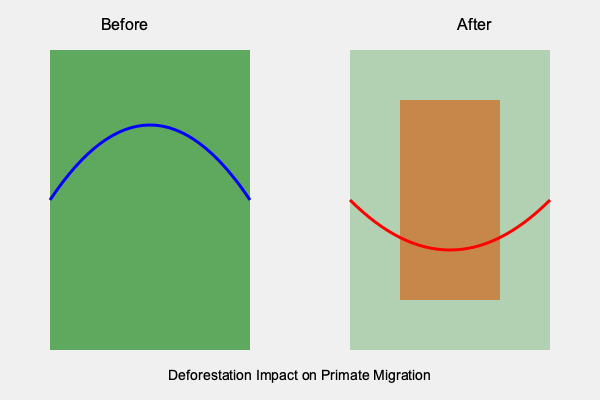Based on the satellite imagery showing primate migration paths before and after deforestation, calculate the percentage increase in migration distance. Assume the blue path (before) is 100 km long, and the red path (after) forms a semicircle with a diameter equal to the width of the deforested area. The deforested area is 50% of the total forest width. To solve this problem, we'll follow these steps:

1. Identify the initial migration distance:
   - The blue path (before deforestation) is given as 100 km long.

2. Calculate the new migration distance after deforestation:
   - The red path forms a semicircle.
   - The diameter of this semicircle is equal to the width of the deforested area.
   - The deforested area is 50% of the total forest width.

3. Calculate the length of the semicircular path:
   - The circumference of a full circle is given by $C = 2\pi r$, where $r$ is the radius.
   - For a semicircle, we use half of this: $C_{semicircle} = \pi r$
   - The diameter (d) is the width of the deforested area, which is 50% of 100 km = 50 km
   - Radius (r) is half of the diameter: $r = 25$ km
   - Length of semicircular path = $\pi r = \pi \cdot 25 \approx 78.54$ km

4. Calculate the percentage increase:
   - Percentage increase = $\frac{\text{New distance} - \text{Original distance}}{\text{Original distance}} \times 100\%$
   - $= \frac{78.54 - 100}{100} \times 100\% \approx -21.46\%$

The negative percentage indicates a decrease in migration distance.

5. Convert to absolute percentage change:
   - Absolute percentage change = $|{-21.46\%}| = 21.46\%$
Answer: 21.46% decrease 